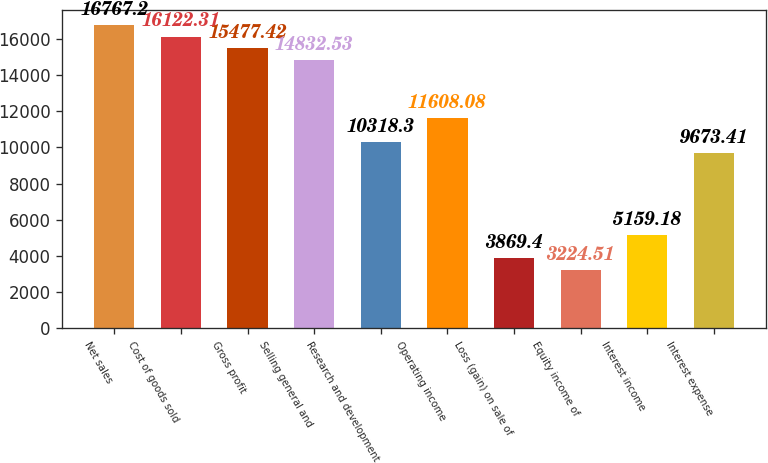Convert chart to OTSL. <chart><loc_0><loc_0><loc_500><loc_500><bar_chart><fcel>Net sales<fcel>Cost of goods sold<fcel>Gross profit<fcel>Selling general and<fcel>Research and development<fcel>Operating income<fcel>Loss (gain) on sale of<fcel>Equity income of<fcel>Interest income<fcel>Interest expense<nl><fcel>16767.2<fcel>16122.3<fcel>15477.4<fcel>14832.5<fcel>10318.3<fcel>11608.1<fcel>3869.4<fcel>3224.51<fcel>5159.18<fcel>9673.41<nl></chart> 